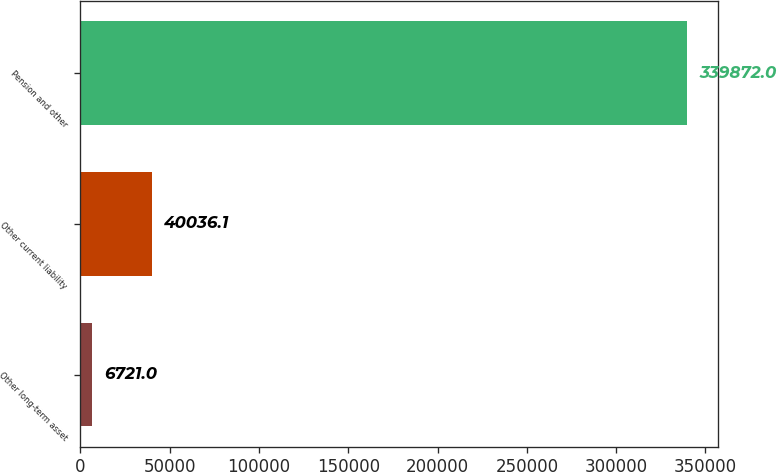Convert chart. <chart><loc_0><loc_0><loc_500><loc_500><bar_chart><fcel>Other long-term asset<fcel>Other current liability<fcel>Pension and other<nl><fcel>6721<fcel>40036.1<fcel>339872<nl></chart> 